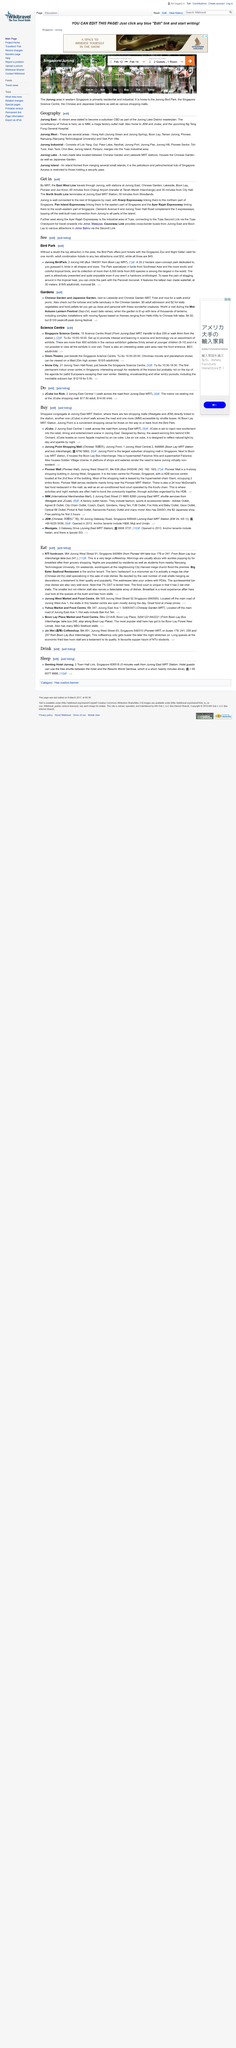Highlight a few significant elements in this photo. The title of this page is "Geography. This webpage is about the topic of Jurong. This article explores three areas of Jurong: East, West, and Industrial. 